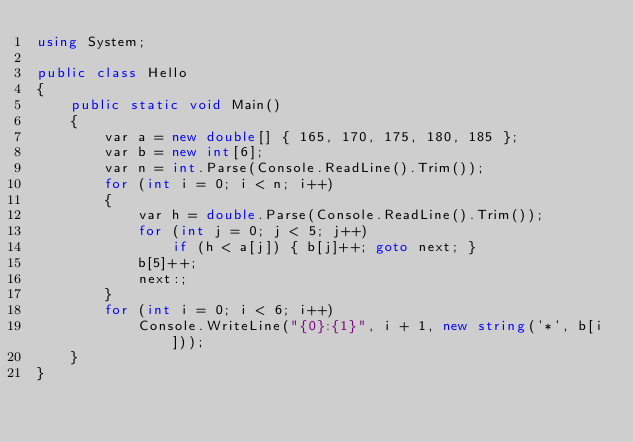<code> <loc_0><loc_0><loc_500><loc_500><_C#_>using System;

public class Hello
{
    public static void Main()
    {
        var a = new double[] { 165, 170, 175, 180, 185 };
        var b = new int[6];
        var n = int.Parse(Console.ReadLine().Trim());
        for (int i = 0; i < n; i++)
        {
            var h = double.Parse(Console.ReadLine().Trim());
            for (int j = 0; j < 5; j++)
                if (h < a[j]) { b[j]++; goto next; }
            b[5]++;
            next:;
        }
        for (int i = 0; i < 6; i++)
            Console.WriteLine("{0}:{1}", i + 1, new string('*', b[i]));
    }
}

</code> 